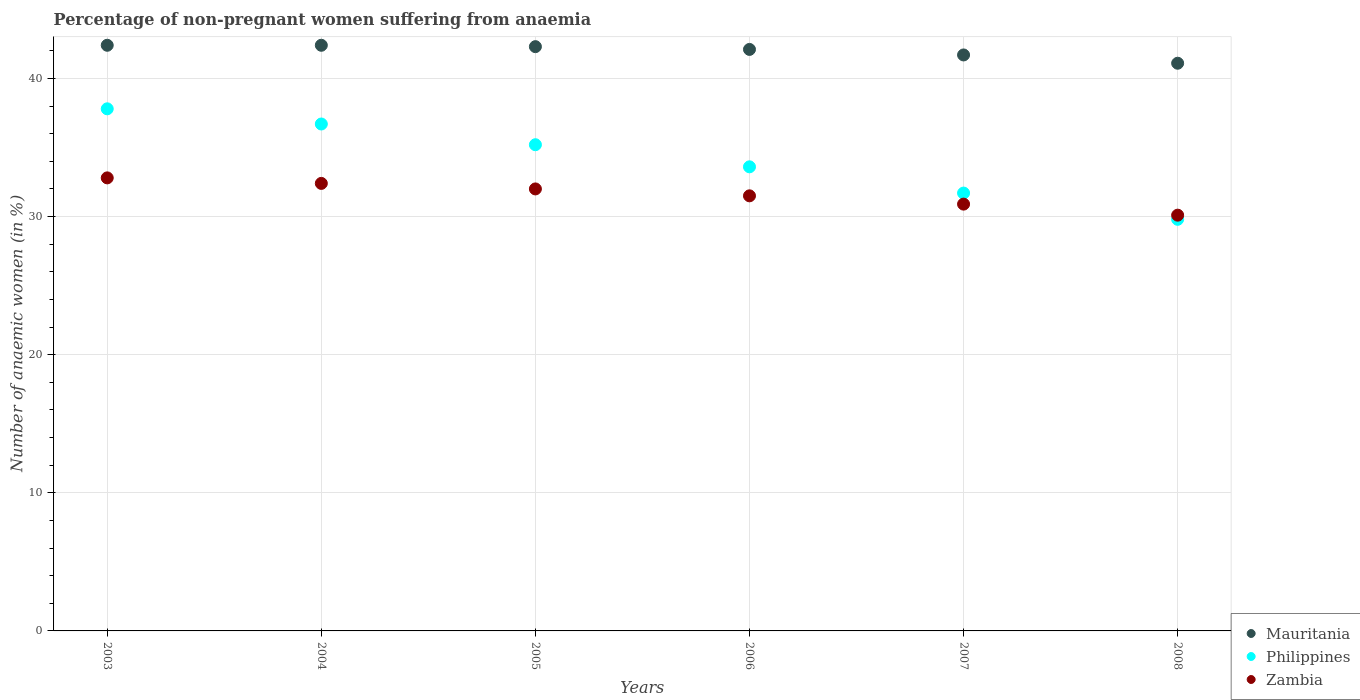Is the number of dotlines equal to the number of legend labels?
Ensure brevity in your answer.  Yes. What is the percentage of non-pregnant women suffering from anaemia in Zambia in 2006?
Your answer should be compact. 31.5. Across all years, what is the maximum percentage of non-pregnant women suffering from anaemia in Zambia?
Make the answer very short. 32.8. Across all years, what is the minimum percentage of non-pregnant women suffering from anaemia in Zambia?
Offer a terse response. 30.1. In which year was the percentage of non-pregnant women suffering from anaemia in Mauritania minimum?
Your answer should be very brief. 2008. What is the total percentage of non-pregnant women suffering from anaemia in Mauritania in the graph?
Make the answer very short. 252. What is the difference between the percentage of non-pregnant women suffering from anaemia in Mauritania in 2003 and that in 2006?
Provide a succinct answer. 0.3. What is the difference between the percentage of non-pregnant women suffering from anaemia in Philippines in 2003 and the percentage of non-pregnant women suffering from anaemia in Zambia in 2005?
Offer a terse response. 5.8. What is the average percentage of non-pregnant women suffering from anaemia in Zambia per year?
Offer a very short reply. 31.62. In the year 2008, what is the difference between the percentage of non-pregnant women suffering from anaemia in Zambia and percentage of non-pregnant women suffering from anaemia in Philippines?
Ensure brevity in your answer.  0.3. In how many years, is the percentage of non-pregnant women suffering from anaemia in Mauritania greater than 12 %?
Your answer should be very brief. 6. What is the ratio of the percentage of non-pregnant women suffering from anaemia in Philippines in 2004 to that in 2008?
Offer a terse response. 1.23. Is the percentage of non-pregnant women suffering from anaemia in Mauritania in 2006 less than that in 2008?
Ensure brevity in your answer.  No. What is the difference between the highest and the second highest percentage of non-pregnant women suffering from anaemia in Philippines?
Make the answer very short. 1.1. What is the difference between the highest and the lowest percentage of non-pregnant women suffering from anaemia in Zambia?
Your answer should be very brief. 2.7. Is it the case that in every year, the sum of the percentage of non-pregnant women suffering from anaemia in Mauritania and percentage of non-pregnant women suffering from anaemia in Philippines  is greater than the percentage of non-pregnant women suffering from anaemia in Zambia?
Your response must be concise. Yes. How many dotlines are there?
Ensure brevity in your answer.  3. What is the difference between two consecutive major ticks on the Y-axis?
Offer a terse response. 10. Where does the legend appear in the graph?
Your answer should be very brief. Bottom right. How many legend labels are there?
Provide a short and direct response. 3. How are the legend labels stacked?
Your response must be concise. Vertical. What is the title of the graph?
Your answer should be compact. Percentage of non-pregnant women suffering from anaemia. What is the label or title of the Y-axis?
Provide a succinct answer. Number of anaemic women (in %). What is the Number of anaemic women (in %) in Mauritania in 2003?
Ensure brevity in your answer.  42.4. What is the Number of anaemic women (in %) in Philippines in 2003?
Keep it short and to the point. 37.8. What is the Number of anaemic women (in %) of Zambia in 2003?
Offer a very short reply. 32.8. What is the Number of anaemic women (in %) of Mauritania in 2004?
Keep it short and to the point. 42.4. What is the Number of anaemic women (in %) of Philippines in 2004?
Give a very brief answer. 36.7. What is the Number of anaemic women (in %) in Zambia in 2004?
Offer a terse response. 32.4. What is the Number of anaemic women (in %) in Mauritania in 2005?
Provide a succinct answer. 42.3. What is the Number of anaemic women (in %) in Philippines in 2005?
Your answer should be very brief. 35.2. What is the Number of anaemic women (in %) in Mauritania in 2006?
Offer a terse response. 42.1. What is the Number of anaemic women (in %) of Philippines in 2006?
Your answer should be compact. 33.6. What is the Number of anaemic women (in %) of Zambia in 2006?
Keep it short and to the point. 31.5. What is the Number of anaemic women (in %) in Mauritania in 2007?
Your response must be concise. 41.7. What is the Number of anaemic women (in %) in Philippines in 2007?
Ensure brevity in your answer.  31.7. What is the Number of anaemic women (in %) in Zambia in 2007?
Keep it short and to the point. 30.9. What is the Number of anaemic women (in %) in Mauritania in 2008?
Provide a succinct answer. 41.1. What is the Number of anaemic women (in %) in Philippines in 2008?
Ensure brevity in your answer.  29.8. What is the Number of anaemic women (in %) of Zambia in 2008?
Your response must be concise. 30.1. Across all years, what is the maximum Number of anaemic women (in %) of Mauritania?
Provide a succinct answer. 42.4. Across all years, what is the maximum Number of anaemic women (in %) of Philippines?
Make the answer very short. 37.8. Across all years, what is the maximum Number of anaemic women (in %) of Zambia?
Keep it short and to the point. 32.8. Across all years, what is the minimum Number of anaemic women (in %) of Mauritania?
Provide a succinct answer. 41.1. Across all years, what is the minimum Number of anaemic women (in %) in Philippines?
Offer a very short reply. 29.8. Across all years, what is the minimum Number of anaemic women (in %) in Zambia?
Offer a terse response. 30.1. What is the total Number of anaemic women (in %) in Mauritania in the graph?
Ensure brevity in your answer.  252. What is the total Number of anaemic women (in %) in Philippines in the graph?
Provide a short and direct response. 204.8. What is the total Number of anaemic women (in %) in Zambia in the graph?
Your answer should be very brief. 189.7. What is the difference between the Number of anaemic women (in %) in Mauritania in 2003 and that in 2004?
Provide a short and direct response. 0. What is the difference between the Number of anaemic women (in %) of Philippines in 2003 and that in 2004?
Give a very brief answer. 1.1. What is the difference between the Number of anaemic women (in %) of Zambia in 2003 and that in 2005?
Offer a very short reply. 0.8. What is the difference between the Number of anaemic women (in %) in Mauritania in 2003 and that in 2006?
Your answer should be very brief. 0.3. What is the difference between the Number of anaemic women (in %) in Philippines in 2003 and that in 2007?
Make the answer very short. 6.1. What is the difference between the Number of anaemic women (in %) of Zambia in 2003 and that in 2008?
Your answer should be very brief. 2.7. What is the difference between the Number of anaemic women (in %) in Philippines in 2004 and that in 2005?
Provide a short and direct response. 1.5. What is the difference between the Number of anaemic women (in %) in Philippines in 2004 and that in 2006?
Provide a succinct answer. 3.1. What is the difference between the Number of anaemic women (in %) in Zambia in 2004 and that in 2006?
Offer a terse response. 0.9. What is the difference between the Number of anaemic women (in %) of Mauritania in 2004 and that in 2007?
Offer a terse response. 0.7. What is the difference between the Number of anaemic women (in %) in Philippines in 2004 and that in 2007?
Give a very brief answer. 5. What is the difference between the Number of anaemic women (in %) in Zambia in 2004 and that in 2007?
Ensure brevity in your answer.  1.5. What is the difference between the Number of anaemic women (in %) of Mauritania in 2004 and that in 2008?
Offer a very short reply. 1.3. What is the difference between the Number of anaemic women (in %) in Zambia in 2004 and that in 2008?
Your answer should be compact. 2.3. What is the difference between the Number of anaemic women (in %) of Mauritania in 2005 and that in 2006?
Your answer should be very brief. 0.2. What is the difference between the Number of anaemic women (in %) of Philippines in 2005 and that in 2006?
Ensure brevity in your answer.  1.6. What is the difference between the Number of anaemic women (in %) in Philippines in 2005 and that in 2007?
Offer a terse response. 3.5. What is the difference between the Number of anaemic women (in %) of Zambia in 2005 and that in 2007?
Your answer should be compact. 1.1. What is the difference between the Number of anaemic women (in %) of Philippines in 2006 and that in 2008?
Your answer should be very brief. 3.8. What is the difference between the Number of anaemic women (in %) of Zambia in 2006 and that in 2008?
Provide a short and direct response. 1.4. What is the difference between the Number of anaemic women (in %) in Mauritania in 2007 and that in 2008?
Your response must be concise. 0.6. What is the difference between the Number of anaemic women (in %) of Zambia in 2007 and that in 2008?
Your answer should be very brief. 0.8. What is the difference between the Number of anaemic women (in %) in Mauritania in 2003 and the Number of anaemic women (in %) in Philippines in 2004?
Your answer should be compact. 5.7. What is the difference between the Number of anaemic women (in %) in Mauritania in 2003 and the Number of anaemic women (in %) in Zambia in 2005?
Provide a short and direct response. 10.4. What is the difference between the Number of anaemic women (in %) of Mauritania in 2003 and the Number of anaemic women (in %) of Zambia in 2006?
Your response must be concise. 10.9. What is the difference between the Number of anaemic women (in %) in Philippines in 2003 and the Number of anaemic women (in %) in Zambia in 2006?
Ensure brevity in your answer.  6.3. What is the difference between the Number of anaemic women (in %) of Mauritania in 2003 and the Number of anaemic women (in %) of Philippines in 2007?
Keep it short and to the point. 10.7. What is the difference between the Number of anaemic women (in %) in Mauritania in 2003 and the Number of anaemic women (in %) in Zambia in 2007?
Your answer should be very brief. 11.5. What is the difference between the Number of anaemic women (in %) of Mauritania in 2003 and the Number of anaemic women (in %) of Zambia in 2008?
Your response must be concise. 12.3. What is the difference between the Number of anaemic women (in %) of Mauritania in 2004 and the Number of anaemic women (in %) of Zambia in 2005?
Offer a terse response. 10.4. What is the difference between the Number of anaemic women (in %) in Mauritania in 2004 and the Number of anaemic women (in %) in Philippines in 2006?
Keep it short and to the point. 8.8. What is the difference between the Number of anaemic women (in %) in Philippines in 2004 and the Number of anaemic women (in %) in Zambia in 2006?
Provide a succinct answer. 5.2. What is the difference between the Number of anaemic women (in %) of Mauritania in 2004 and the Number of anaemic women (in %) of Philippines in 2007?
Offer a terse response. 10.7. What is the difference between the Number of anaemic women (in %) in Mauritania in 2004 and the Number of anaemic women (in %) in Zambia in 2007?
Ensure brevity in your answer.  11.5. What is the difference between the Number of anaemic women (in %) in Philippines in 2004 and the Number of anaemic women (in %) in Zambia in 2007?
Give a very brief answer. 5.8. What is the difference between the Number of anaemic women (in %) in Mauritania in 2004 and the Number of anaemic women (in %) in Philippines in 2008?
Offer a terse response. 12.6. What is the difference between the Number of anaemic women (in %) of Mauritania in 2004 and the Number of anaemic women (in %) of Zambia in 2008?
Ensure brevity in your answer.  12.3. What is the difference between the Number of anaemic women (in %) in Mauritania in 2005 and the Number of anaemic women (in %) in Philippines in 2006?
Offer a terse response. 8.7. What is the difference between the Number of anaemic women (in %) in Mauritania in 2005 and the Number of anaemic women (in %) in Zambia in 2006?
Offer a terse response. 10.8. What is the difference between the Number of anaemic women (in %) in Philippines in 2005 and the Number of anaemic women (in %) in Zambia in 2006?
Your answer should be very brief. 3.7. What is the difference between the Number of anaemic women (in %) in Mauritania in 2005 and the Number of anaemic women (in %) in Philippines in 2007?
Your answer should be very brief. 10.6. What is the difference between the Number of anaemic women (in %) in Mauritania in 2005 and the Number of anaemic women (in %) in Zambia in 2007?
Provide a succinct answer. 11.4. What is the difference between the Number of anaemic women (in %) of Mauritania in 2005 and the Number of anaemic women (in %) of Philippines in 2008?
Your answer should be very brief. 12.5. What is the difference between the Number of anaemic women (in %) of Philippines in 2005 and the Number of anaemic women (in %) of Zambia in 2008?
Provide a succinct answer. 5.1. What is the difference between the Number of anaemic women (in %) of Mauritania in 2006 and the Number of anaemic women (in %) of Philippines in 2007?
Your response must be concise. 10.4. What is the difference between the Number of anaemic women (in %) in Mauritania in 2006 and the Number of anaemic women (in %) in Zambia in 2007?
Make the answer very short. 11.2. What is the difference between the Number of anaemic women (in %) of Philippines in 2006 and the Number of anaemic women (in %) of Zambia in 2007?
Make the answer very short. 2.7. What is the difference between the Number of anaemic women (in %) in Mauritania in 2006 and the Number of anaemic women (in %) in Philippines in 2008?
Your answer should be very brief. 12.3. What is the difference between the Number of anaemic women (in %) in Mauritania in 2007 and the Number of anaemic women (in %) in Zambia in 2008?
Keep it short and to the point. 11.6. What is the average Number of anaemic women (in %) of Mauritania per year?
Make the answer very short. 42. What is the average Number of anaemic women (in %) of Philippines per year?
Keep it short and to the point. 34.13. What is the average Number of anaemic women (in %) in Zambia per year?
Offer a very short reply. 31.62. In the year 2003, what is the difference between the Number of anaemic women (in %) of Mauritania and Number of anaemic women (in %) of Philippines?
Offer a very short reply. 4.6. In the year 2003, what is the difference between the Number of anaemic women (in %) of Philippines and Number of anaemic women (in %) of Zambia?
Offer a terse response. 5. In the year 2004, what is the difference between the Number of anaemic women (in %) in Mauritania and Number of anaemic women (in %) in Philippines?
Offer a terse response. 5.7. In the year 2004, what is the difference between the Number of anaemic women (in %) in Mauritania and Number of anaemic women (in %) in Zambia?
Ensure brevity in your answer.  10. In the year 2004, what is the difference between the Number of anaemic women (in %) of Philippines and Number of anaemic women (in %) of Zambia?
Offer a terse response. 4.3. In the year 2005, what is the difference between the Number of anaemic women (in %) of Mauritania and Number of anaemic women (in %) of Philippines?
Your answer should be very brief. 7.1. In the year 2005, what is the difference between the Number of anaemic women (in %) of Mauritania and Number of anaemic women (in %) of Zambia?
Provide a succinct answer. 10.3. In the year 2005, what is the difference between the Number of anaemic women (in %) in Philippines and Number of anaemic women (in %) in Zambia?
Offer a very short reply. 3.2. In the year 2006, what is the difference between the Number of anaemic women (in %) in Mauritania and Number of anaemic women (in %) in Philippines?
Your response must be concise. 8.5. In the year 2006, what is the difference between the Number of anaemic women (in %) of Mauritania and Number of anaemic women (in %) of Zambia?
Keep it short and to the point. 10.6. In the year 2007, what is the difference between the Number of anaemic women (in %) in Mauritania and Number of anaemic women (in %) in Zambia?
Make the answer very short. 10.8. In the year 2008, what is the difference between the Number of anaemic women (in %) of Philippines and Number of anaemic women (in %) of Zambia?
Offer a terse response. -0.3. What is the ratio of the Number of anaemic women (in %) in Mauritania in 2003 to that in 2004?
Your answer should be compact. 1. What is the ratio of the Number of anaemic women (in %) of Zambia in 2003 to that in 2004?
Your response must be concise. 1.01. What is the ratio of the Number of anaemic women (in %) in Philippines in 2003 to that in 2005?
Your answer should be very brief. 1.07. What is the ratio of the Number of anaemic women (in %) in Zambia in 2003 to that in 2005?
Ensure brevity in your answer.  1.02. What is the ratio of the Number of anaemic women (in %) of Mauritania in 2003 to that in 2006?
Provide a succinct answer. 1.01. What is the ratio of the Number of anaemic women (in %) in Zambia in 2003 to that in 2006?
Give a very brief answer. 1.04. What is the ratio of the Number of anaemic women (in %) in Mauritania in 2003 to that in 2007?
Your answer should be compact. 1.02. What is the ratio of the Number of anaemic women (in %) in Philippines in 2003 to that in 2007?
Ensure brevity in your answer.  1.19. What is the ratio of the Number of anaemic women (in %) of Zambia in 2003 to that in 2007?
Ensure brevity in your answer.  1.06. What is the ratio of the Number of anaemic women (in %) of Mauritania in 2003 to that in 2008?
Your response must be concise. 1.03. What is the ratio of the Number of anaemic women (in %) of Philippines in 2003 to that in 2008?
Offer a very short reply. 1.27. What is the ratio of the Number of anaemic women (in %) of Zambia in 2003 to that in 2008?
Make the answer very short. 1.09. What is the ratio of the Number of anaemic women (in %) of Philippines in 2004 to that in 2005?
Give a very brief answer. 1.04. What is the ratio of the Number of anaemic women (in %) in Zambia in 2004 to that in 2005?
Your answer should be compact. 1.01. What is the ratio of the Number of anaemic women (in %) of Mauritania in 2004 to that in 2006?
Offer a terse response. 1.01. What is the ratio of the Number of anaemic women (in %) in Philippines in 2004 to that in 2006?
Give a very brief answer. 1.09. What is the ratio of the Number of anaemic women (in %) in Zambia in 2004 to that in 2006?
Your answer should be compact. 1.03. What is the ratio of the Number of anaemic women (in %) in Mauritania in 2004 to that in 2007?
Your answer should be compact. 1.02. What is the ratio of the Number of anaemic women (in %) in Philippines in 2004 to that in 2007?
Give a very brief answer. 1.16. What is the ratio of the Number of anaemic women (in %) of Zambia in 2004 to that in 2007?
Keep it short and to the point. 1.05. What is the ratio of the Number of anaemic women (in %) in Mauritania in 2004 to that in 2008?
Give a very brief answer. 1.03. What is the ratio of the Number of anaemic women (in %) in Philippines in 2004 to that in 2008?
Make the answer very short. 1.23. What is the ratio of the Number of anaemic women (in %) in Zambia in 2004 to that in 2008?
Keep it short and to the point. 1.08. What is the ratio of the Number of anaemic women (in %) of Philippines in 2005 to that in 2006?
Provide a short and direct response. 1.05. What is the ratio of the Number of anaemic women (in %) in Zambia in 2005 to that in 2006?
Offer a terse response. 1.02. What is the ratio of the Number of anaemic women (in %) of Mauritania in 2005 to that in 2007?
Keep it short and to the point. 1.01. What is the ratio of the Number of anaemic women (in %) of Philippines in 2005 to that in 2007?
Make the answer very short. 1.11. What is the ratio of the Number of anaemic women (in %) of Zambia in 2005 to that in 2007?
Your response must be concise. 1.04. What is the ratio of the Number of anaemic women (in %) in Mauritania in 2005 to that in 2008?
Offer a terse response. 1.03. What is the ratio of the Number of anaemic women (in %) in Philippines in 2005 to that in 2008?
Give a very brief answer. 1.18. What is the ratio of the Number of anaemic women (in %) of Zambia in 2005 to that in 2008?
Your answer should be compact. 1.06. What is the ratio of the Number of anaemic women (in %) of Mauritania in 2006 to that in 2007?
Give a very brief answer. 1.01. What is the ratio of the Number of anaemic women (in %) in Philippines in 2006 to that in 2007?
Your response must be concise. 1.06. What is the ratio of the Number of anaemic women (in %) of Zambia in 2006 to that in 2007?
Give a very brief answer. 1.02. What is the ratio of the Number of anaemic women (in %) in Mauritania in 2006 to that in 2008?
Offer a terse response. 1.02. What is the ratio of the Number of anaemic women (in %) of Philippines in 2006 to that in 2008?
Provide a short and direct response. 1.13. What is the ratio of the Number of anaemic women (in %) of Zambia in 2006 to that in 2008?
Offer a terse response. 1.05. What is the ratio of the Number of anaemic women (in %) in Mauritania in 2007 to that in 2008?
Offer a terse response. 1.01. What is the ratio of the Number of anaemic women (in %) in Philippines in 2007 to that in 2008?
Your response must be concise. 1.06. What is the ratio of the Number of anaemic women (in %) in Zambia in 2007 to that in 2008?
Provide a short and direct response. 1.03. What is the difference between the highest and the second highest Number of anaemic women (in %) in Mauritania?
Offer a very short reply. 0. What is the difference between the highest and the second highest Number of anaemic women (in %) in Zambia?
Ensure brevity in your answer.  0.4. What is the difference between the highest and the lowest Number of anaemic women (in %) in Philippines?
Offer a very short reply. 8. 